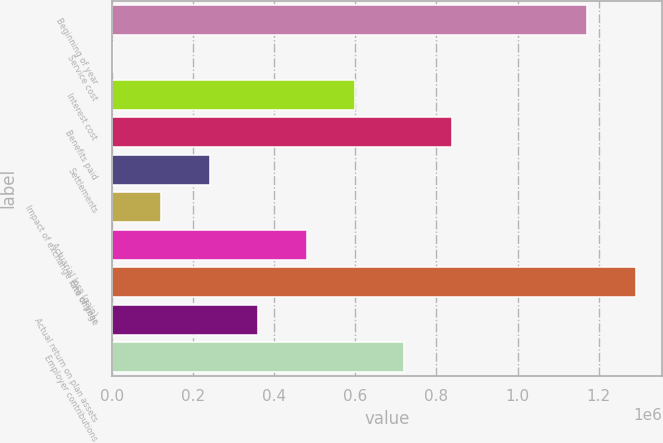<chart> <loc_0><loc_0><loc_500><loc_500><bar_chart><fcel>Beginning of year<fcel>Service cost<fcel>Interest cost<fcel>Benefits paid<fcel>Settlements<fcel>Impact of exchange rate change<fcel>Actuarial loss (gain)<fcel>End of year<fcel>Actual return on plan assets<fcel>Employer contributions<nl><fcel>1.17227e+06<fcel>1856<fcel>599522<fcel>838589<fcel>240923<fcel>121389<fcel>479989<fcel>1.2918e+06<fcel>360456<fcel>719056<nl></chart> 